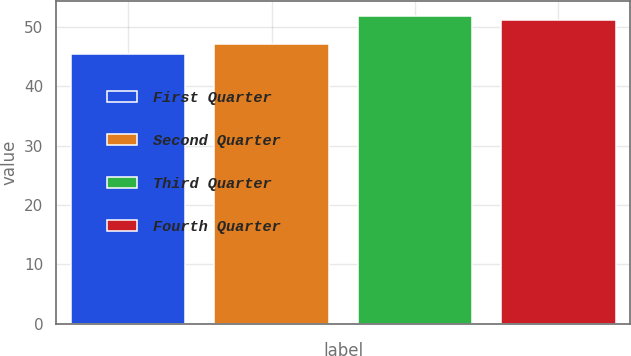<chart> <loc_0><loc_0><loc_500><loc_500><bar_chart><fcel>First Quarter<fcel>Second Quarter<fcel>Third Quarter<fcel>Fourth Quarter<nl><fcel>45.38<fcel>47.16<fcel>51.85<fcel>51.15<nl></chart> 